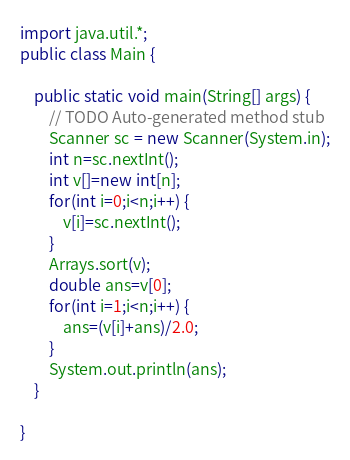Convert code to text. <code><loc_0><loc_0><loc_500><loc_500><_Java_>import java.util.*;
public class Main {

	public static void main(String[] args) {
		// TODO Auto-generated method stub
		Scanner sc = new Scanner(System.in);
		int n=sc.nextInt();
		int v[]=new int[n];
		for(int i=0;i<n;i++) {
			v[i]=sc.nextInt();
		}
		Arrays.sort(v);
		double ans=v[0];
		for(int i=1;i<n;i++) {
			ans=(v[i]+ans)/2.0;
		}
		System.out.println(ans);
	}

}
</code> 